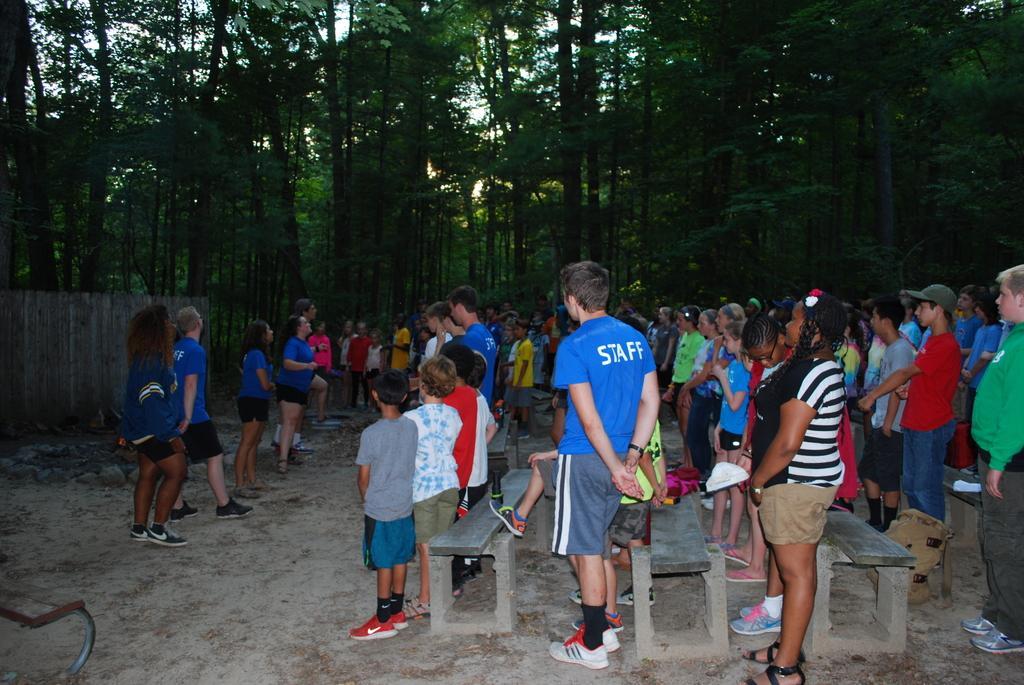Please provide a concise description of this image. In this image I can see a group of people standing on the floor and I can see benches visible in the foreground ,at the top I can see trees. 